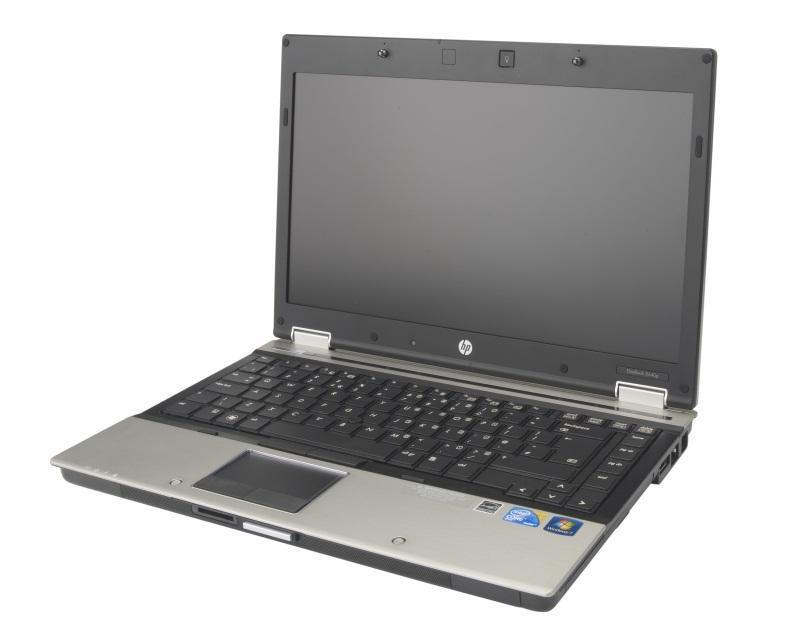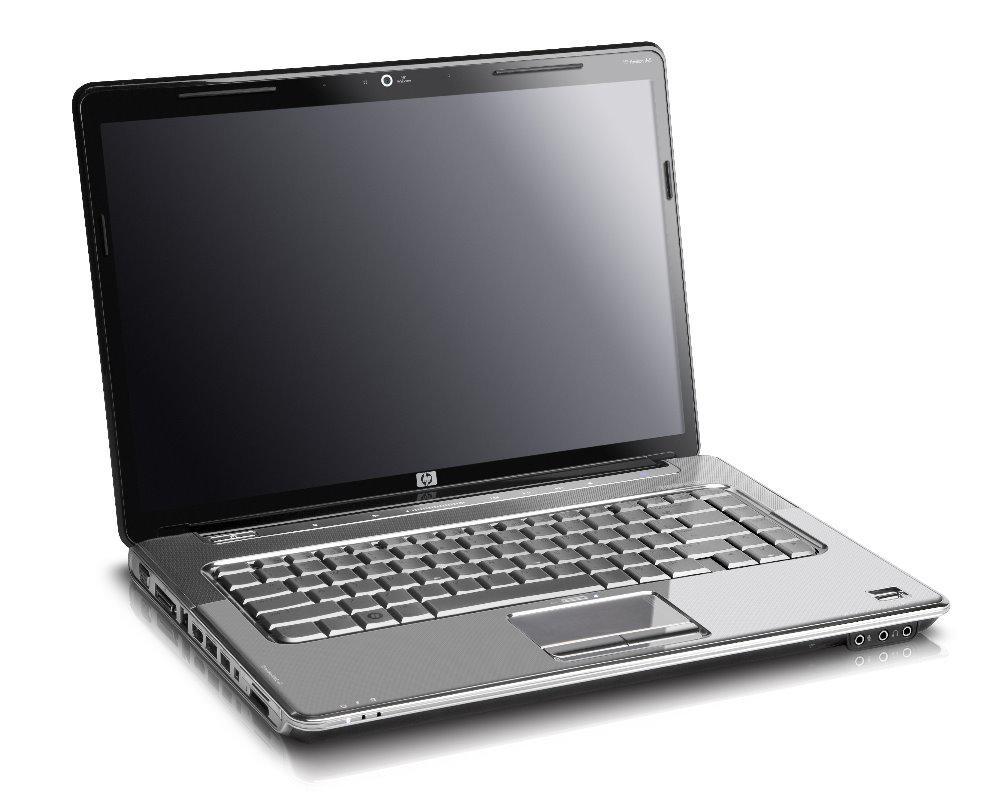The first image is the image on the left, the second image is the image on the right. For the images shown, is this caption "All devices feature screens with images on them." true? Answer yes or no. No. 